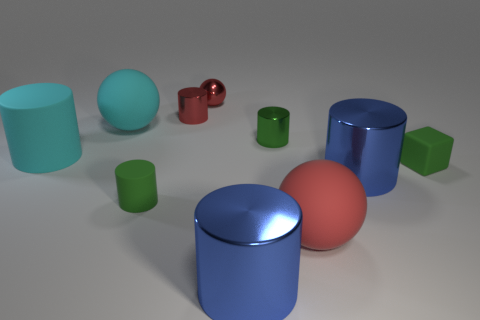There is a matte object that is the same color as the small cube; what size is it?
Your answer should be compact. Small. There is a small green cylinder that is left of the green metal cylinder; what is its material?
Give a very brief answer. Rubber. Is there any other thing that is the same color as the rubber block?
Offer a very short reply. Yes. What is the size of the red ball that is the same material as the red cylinder?
Your response must be concise. Small. How many tiny objects are green rubber cylinders or metallic balls?
Make the answer very short. 2. There is a green cylinder in front of the tiny cylinder on the right side of the red ball that is behind the cyan rubber cylinder; how big is it?
Offer a very short reply. Small. What number of red cylinders have the same size as the green rubber block?
Your answer should be compact. 1. How many objects are either large cyan rubber cylinders or metal things that are on the left side of the red rubber thing?
Your answer should be very brief. 5. What is the shape of the big red object?
Provide a short and direct response. Sphere. Is the small cube the same color as the tiny metal ball?
Ensure brevity in your answer.  No. 